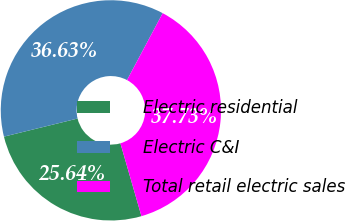Convert chart to OTSL. <chart><loc_0><loc_0><loc_500><loc_500><pie_chart><fcel>Electric residential<fcel>Electric C&I<fcel>Total retail electric sales<nl><fcel>25.64%<fcel>36.63%<fcel>37.73%<nl></chart> 